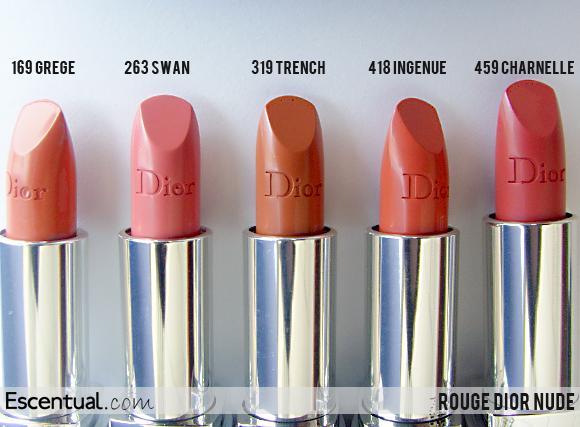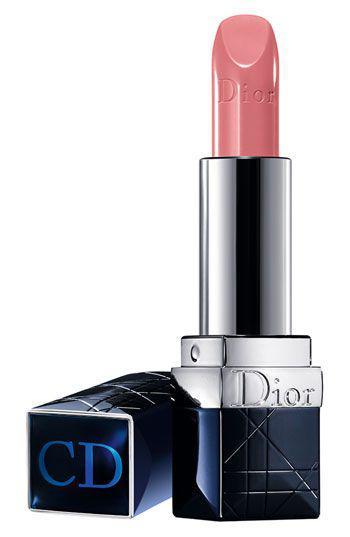The first image is the image on the left, the second image is the image on the right. Assess this claim about the two images: "One of the images shows a single lipstick on display and the other shows a group of at least three lipsticks.". Correct or not? Answer yes or no. Yes. The first image is the image on the left, the second image is the image on the right. Analyze the images presented: Is the assertion "there is a single tuble of lipstick with a black cap next to it" valid? Answer yes or no. Yes. 